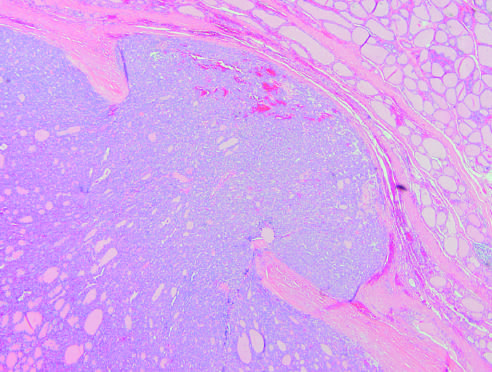what do follicular carcinomas demonstrate?
Answer the question using a single word or phrase. Capsular invasion 